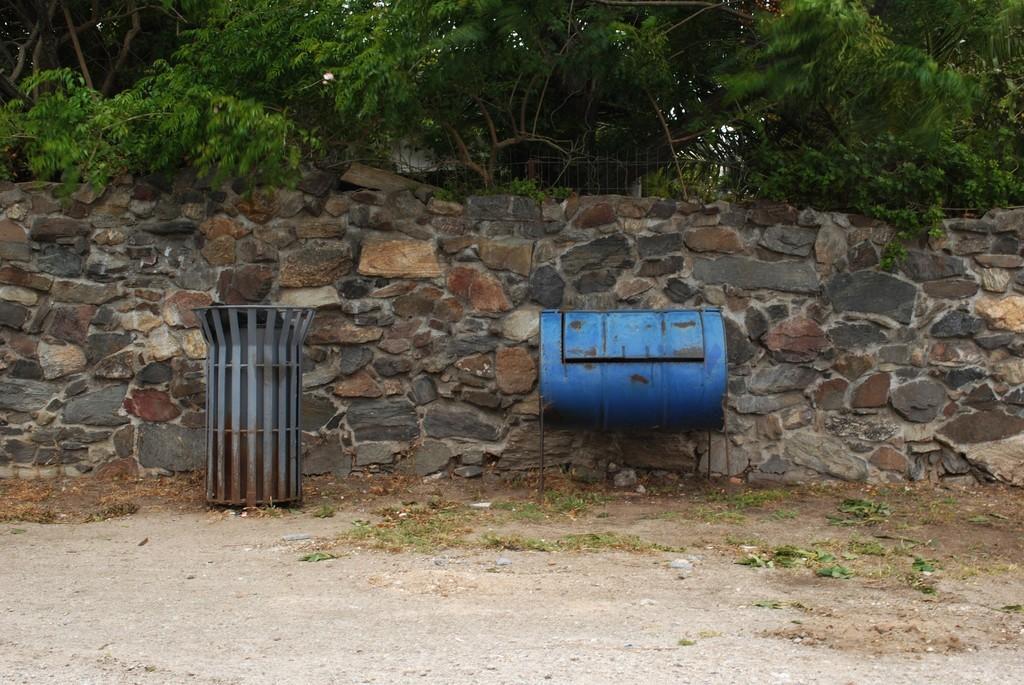Can you describe this image briefly? To the bottom of the image there is a ground with grass on it. There is a bin on the ground to the left side. And beside the bin to the right side there is a blue drum on the stand. Behind them there is a stone wall. Behind the wall to the top of the image there are trees. 